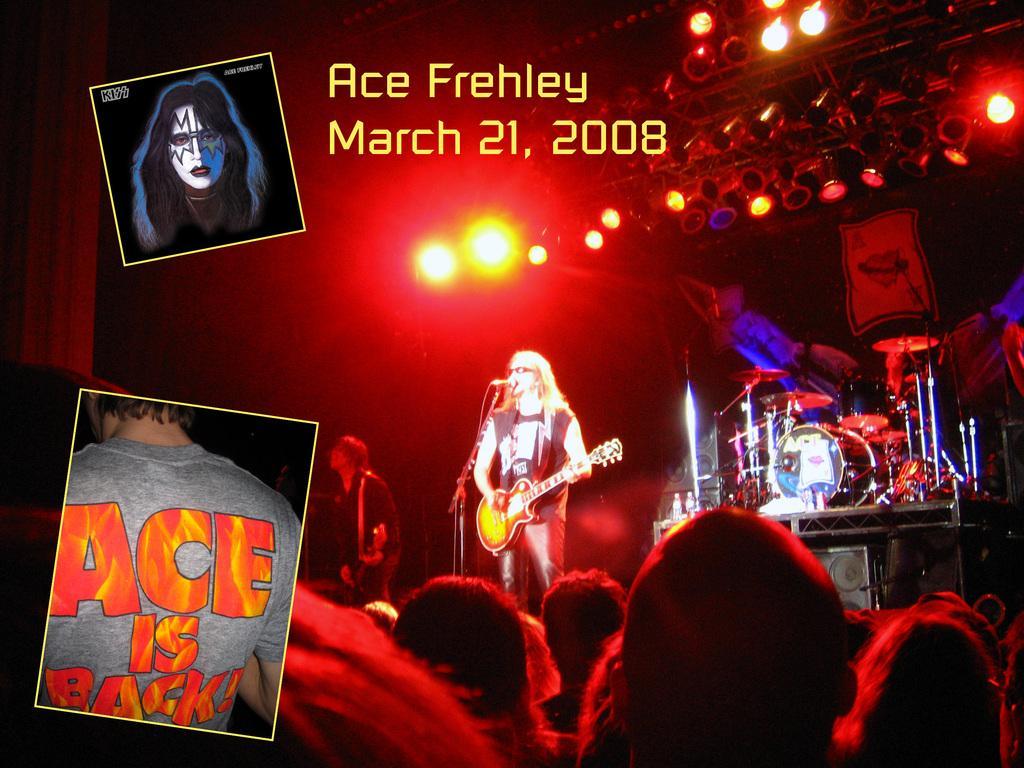In one or two sentences, can you explain what this image depicts? A collage picture. The persons are standing on a stage and singing in-front of a mic and holding a guitar. On top there are focusing lights. This are musical instruments. This are audience. This is a poster. 